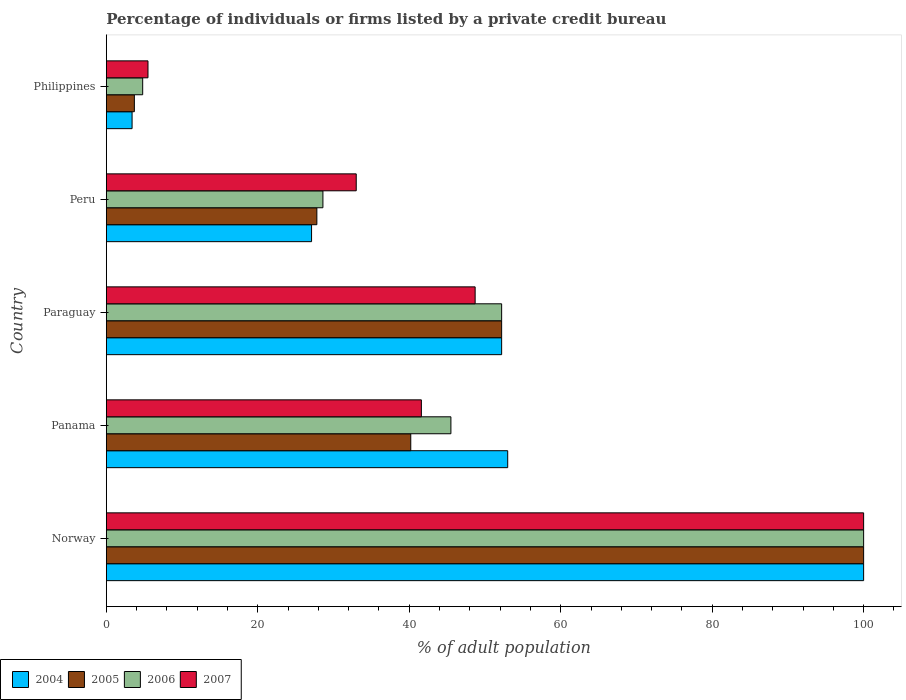Are the number of bars per tick equal to the number of legend labels?
Give a very brief answer. Yes. What is the label of the 4th group of bars from the top?
Provide a succinct answer. Panama. What is the percentage of population listed by a private credit bureau in 2006 in Peru?
Provide a succinct answer. 28.6. Across all countries, what is the maximum percentage of population listed by a private credit bureau in 2006?
Keep it short and to the point. 100. What is the total percentage of population listed by a private credit bureau in 2004 in the graph?
Provide a succinct answer. 235.7. What is the difference between the percentage of population listed by a private credit bureau in 2004 in Norway and that in Panama?
Make the answer very short. 47. What is the difference between the percentage of population listed by a private credit bureau in 2007 in Norway and the percentage of population listed by a private credit bureau in 2006 in Philippines?
Keep it short and to the point. 95.2. What is the average percentage of population listed by a private credit bureau in 2007 per country?
Your answer should be compact. 45.76. What is the difference between the percentage of population listed by a private credit bureau in 2006 and percentage of population listed by a private credit bureau in 2004 in Peru?
Your answer should be compact. 1.5. In how many countries, is the percentage of population listed by a private credit bureau in 2004 greater than 48 %?
Your answer should be compact. 3. What is the ratio of the percentage of population listed by a private credit bureau in 2004 in Panama to that in Philippines?
Offer a terse response. 15.59. Is the difference between the percentage of population listed by a private credit bureau in 2006 in Paraguay and Peru greater than the difference between the percentage of population listed by a private credit bureau in 2004 in Paraguay and Peru?
Ensure brevity in your answer.  No. What is the difference between the highest and the second highest percentage of population listed by a private credit bureau in 2004?
Your response must be concise. 47. What is the difference between the highest and the lowest percentage of population listed by a private credit bureau in 2004?
Provide a short and direct response. 96.6. In how many countries, is the percentage of population listed by a private credit bureau in 2007 greater than the average percentage of population listed by a private credit bureau in 2007 taken over all countries?
Your response must be concise. 2. Is the sum of the percentage of population listed by a private credit bureau in 2004 in Panama and Philippines greater than the maximum percentage of population listed by a private credit bureau in 2007 across all countries?
Offer a very short reply. No. Is it the case that in every country, the sum of the percentage of population listed by a private credit bureau in 2006 and percentage of population listed by a private credit bureau in 2005 is greater than the sum of percentage of population listed by a private credit bureau in 2007 and percentage of population listed by a private credit bureau in 2004?
Your answer should be very brief. No. What does the 2nd bar from the bottom in Paraguay represents?
Offer a terse response. 2005. Is it the case that in every country, the sum of the percentage of population listed by a private credit bureau in 2005 and percentage of population listed by a private credit bureau in 2006 is greater than the percentage of population listed by a private credit bureau in 2007?
Your answer should be very brief. Yes. How many bars are there?
Ensure brevity in your answer.  20. Are all the bars in the graph horizontal?
Provide a short and direct response. Yes. Where does the legend appear in the graph?
Keep it short and to the point. Bottom left. How many legend labels are there?
Provide a short and direct response. 4. How are the legend labels stacked?
Provide a succinct answer. Horizontal. What is the title of the graph?
Offer a terse response. Percentage of individuals or firms listed by a private credit bureau. What is the label or title of the X-axis?
Ensure brevity in your answer.  % of adult population. What is the % of adult population in 2005 in Norway?
Your answer should be compact. 100. What is the % of adult population in 2006 in Norway?
Provide a short and direct response. 100. What is the % of adult population in 2007 in Norway?
Offer a very short reply. 100. What is the % of adult population of 2004 in Panama?
Keep it short and to the point. 53. What is the % of adult population in 2005 in Panama?
Give a very brief answer. 40.2. What is the % of adult population in 2006 in Panama?
Offer a terse response. 45.5. What is the % of adult population of 2007 in Panama?
Provide a succinct answer. 41.6. What is the % of adult population of 2004 in Paraguay?
Your answer should be compact. 52.2. What is the % of adult population of 2005 in Paraguay?
Your answer should be very brief. 52.2. What is the % of adult population in 2006 in Paraguay?
Keep it short and to the point. 52.2. What is the % of adult population in 2007 in Paraguay?
Provide a short and direct response. 48.7. What is the % of adult population of 2004 in Peru?
Offer a very short reply. 27.1. What is the % of adult population of 2005 in Peru?
Provide a succinct answer. 27.8. What is the % of adult population in 2006 in Peru?
Keep it short and to the point. 28.6. What is the % of adult population of 2007 in Peru?
Your response must be concise. 33. What is the % of adult population of 2004 in Philippines?
Provide a short and direct response. 3.4. What is the % of adult population in 2005 in Philippines?
Offer a very short reply. 3.7. What is the % of adult population of 2007 in Philippines?
Ensure brevity in your answer.  5.5. Across all countries, what is the maximum % of adult population in 2006?
Ensure brevity in your answer.  100. Across all countries, what is the minimum % of adult population of 2006?
Your answer should be very brief. 4.8. What is the total % of adult population in 2004 in the graph?
Ensure brevity in your answer.  235.7. What is the total % of adult population of 2005 in the graph?
Give a very brief answer. 223.9. What is the total % of adult population in 2006 in the graph?
Your response must be concise. 231.1. What is the total % of adult population in 2007 in the graph?
Make the answer very short. 228.8. What is the difference between the % of adult population in 2005 in Norway and that in Panama?
Offer a terse response. 59.8. What is the difference between the % of adult population of 2006 in Norway and that in Panama?
Provide a short and direct response. 54.5. What is the difference between the % of adult population in 2007 in Norway and that in Panama?
Your answer should be very brief. 58.4. What is the difference between the % of adult population of 2004 in Norway and that in Paraguay?
Make the answer very short. 47.8. What is the difference between the % of adult population in 2005 in Norway and that in Paraguay?
Keep it short and to the point. 47.8. What is the difference between the % of adult population of 2006 in Norway and that in Paraguay?
Give a very brief answer. 47.8. What is the difference between the % of adult population of 2007 in Norway and that in Paraguay?
Offer a very short reply. 51.3. What is the difference between the % of adult population in 2004 in Norway and that in Peru?
Your answer should be very brief. 72.9. What is the difference between the % of adult population of 2005 in Norway and that in Peru?
Keep it short and to the point. 72.2. What is the difference between the % of adult population in 2006 in Norway and that in Peru?
Give a very brief answer. 71.4. What is the difference between the % of adult population of 2007 in Norway and that in Peru?
Ensure brevity in your answer.  67. What is the difference between the % of adult population of 2004 in Norway and that in Philippines?
Offer a very short reply. 96.6. What is the difference between the % of adult population of 2005 in Norway and that in Philippines?
Offer a terse response. 96.3. What is the difference between the % of adult population in 2006 in Norway and that in Philippines?
Ensure brevity in your answer.  95.2. What is the difference between the % of adult population of 2007 in Norway and that in Philippines?
Your response must be concise. 94.5. What is the difference between the % of adult population of 2006 in Panama and that in Paraguay?
Keep it short and to the point. -6.7. What is the difference between the % of adult population in 2004 in Panama and that in Peru?
Offer a very short reply. 25.9. What is the difference between the % of adult population of 2005 in Panama and that in Peru?
Ensure brevity in your answer.  12.4. What is the difference between the % of adult population in 2004 in Panama and that in Philippines?
Give a very brief answer. 49.6. What is the difference between the % of adult population of 2005 in Panama and that in Philippines?
Give a very brief answer. 36.5. What is the difference between the % of adult population of 2006 in Panama and that in Philippines?
Offer a terse response. 40.7. What is the difference between the % of adult population in 2007 in Panama and that in Philippines?
Give a very brief answer. 36.1. What is the difference between the % of adult population in 2004 in Paraguay and that in Peru?
Offer a terse response. 25.1. What is the difference between the % of adult population in 2005 in Paraguay and that in Peru?
Offer a terse response. 24.4. What is the difference between the % of adult population in 2006 in Paraguay and that in Peru?
Offer a terse response. 23.6. What is the difference between the % of adult population in 2007 in Paraguay and that in Peru?
Give a very brief answer. 15.7. What is the difference between the % of adult population in 2004 in Paraguay and that in Philippines?
Your answer should be very brief. 48.8. What is the difference between the % of adult population in 2005 in Paraguay and that in Philippines?
Ensure brevity in your answer.  48.5. What is the difference between the % of adult population of 2006 in Paraguay and that in Philippines?
Offer a very short reply. 47.4. What is the difference between the % of adult population of 2007 in Paraguay and that in Philippines?
Provide a succinct answer. 43.2. What is the difference between the % of adult population of 2004 in Peru and that in Philippines?
Provide a succinct answer. 23.7. What is the difference between the % of adult population of 2005 in Peru and that in Philippines?
Make the answer very short. 24.1. What is the difference between the % of adult population of 2006 in Peru and that in Philippines?
Your answer should be very brief. 23.8. What is the difference between the % of adult population of 2007 in Peru and that in Philippines?
Your answer should be compact. 27.5. What is the difference between the % of adult population of 2004 in Norway and the % of adult population of 2005 in Panama?
Offer a very short reply. 59.8. What is the difference between the % of adult population in 2004 in Norway and the % of adult population in 2006 in Panama?
Provide a short and direct response. 54.5. What is the difference between the % of adult population of 2004 in Norway and the % of adult population of 2007 in Panama?
Provide a succinct answer. 58.4. What is the difference between the % of adult population in 2005 in Norway and the % of adult population in 2006 in Panama?
Your response must be concise. 54.5. What is the difference between the % of adult population of 2005 in Norway and the % of adult population of 2007 in Panama?
Keep it short and to the point. 58.4. What is the difference between the % of adult population in 2006 in Norway and the % of adult population in 2007 in Panama?
Provide a short and direct response. 58.4. What is the difference between the % of adult population in 2004 in Norway and the % of adult population in 2005 in Paraguay?
Offer a terse response. 47.8. What is the difference between the % of adult population of 2004 in Norway and the % of adult population of 2006 in Paraguay?
Ensure brevity in your answer.  47.8. What is the difference between the % of adult population in 2004 in Norway and the % of adult population in 2007 in Paraguay?
Make the answer very short. 51.3. What is the difference between the % of adult population in 2005 in Norway and the % of adult population in 2006 in Paraguay?
Your answer should be compact. 47.8. What is the difference between the % of adult population of 2005 in Norway and the % of adult population of 2007 in Paraguay?
Offer a terse response. 51.3. What is the difference between the % of adult population in 2006 in Norway and the % of adult population in 2007 in Paraguay?
Provide a succinct answer. 51.3. What is the difference between the % of adult population in 2004 in Norway and the % of adult population in 2005 in Peru?
Make the answer very short. 72.2. What is the difference between the % of adult population of 2004 in Norway and the % of adult population of 2006 in Peru?
Ensure brevity in your answer.  71.4. What is the difference between the % of adult population in 2005 in Norway and the % of adult population in 2006 in Peru?
Offer a very short reply. 71.4. What is the difference between the % of adult population of 2006 in Norway and the % of adult population of 2007 in Peru?
Make the answer very short. 67. What is the difference between the % of adult population of 2004 in Norway and the % of adult population of 2005 in Philippines?
Give a very brief answer. 96.3. What is the difference between the % of adult population of 2004 in Norway and the % of adult population of 2006 in Philippines?
Give a very brief answer. 95.2. What is the difference between the % of adult population of 2004 in Norway and the % of adult population of 2007 in Philippines?
Your answer should be very brief. 94.5. What is the difference between the % of adult population of 2005 in Norway and the % of adult population of 2006 in Philippines?
Offer a terse response. 95.2. What is the difference between the % of adult population in 2005 in Norway and the % of adult population in 2007 in Philippines?
Provide a short and direct response. 94.5. What is the difference between the % of adult population in 2006 in Norway and the % of adult population in 2007 in Philippines?
Your response must be concise. 94.5. What is the difference between the % of adult population in 2005 in Panama and the % of adult population in 2007 in Paraguay?
Your answer should be compact. -8.5. What is the difference between the % of adult population in 2006 in Panama and the % of adult population in 2007 in Paraguay?
Offer a terse response. -3.2. What is the difference between the % of adult population in 2004 in Panama and the % of adult population in 2005 in Peru?
Make the answer very short. 25.2. What is the difference between the % of adult population in 2004 in Panama and the % of adult population in 2006 in Peru?
Keep it short and to the point. 24.4. What is the difference between the % of adult population in 2004 in Panama and the % of adult population in 2007 in Peru?
Make the answer very short. 20. What is the difference between the % of adult population in 2005 in Panama and the % of adult population in 2006 in Peru?
Offer a very short reply. 11.6. What is the difference between the % of adult population of 2005 in Panama and the % of adult population of 2007 in Peru?
Make the answer very short. 7.2. What is the difference between the % of adult population of 2006 in Panama and the % of adult population of 2007 in Peru?
Make the answer very short. 12.5. What is the difference between the % of adult population in 2004 in Panama and the % of adult population in 2005 in Philippines?
Ensure brevity in your answer.  49.3. What is the difference between the % of adult population in 2004 in Panama and the % of adult population in 2006 in Philippines?
Keep it short and to the point. 48.2. What is the difference between the % of adult population in 2004 in Panama and the % of adult population in 2007 in Philippines?
Offer a very short reply. 47.5. What is the difference between the % of adult population of 2005 in Panama and the % of adult population of 2006 in Philippines?
Make the answer very short. 35.4. What is the difference between the % of adult population in 2005 in Panama and the % of adult population in 2007 in Philippines?
Give a very brief answer. 34.7. What is the difference between the % of adult population in 2006 in Panama and the % of adult population in 2007 in Philippines?
Keep it short and to the point. 40. What is the difference between the % of adult population in 2004 in Paraguay and the % of adult population in 2005 in Peru?
Provide a short and direct response. 24.4. What is the difference between the % of adult population in 2004 in Paraguay and the % of adult population in 2006 in Peru?
Make the answer very short. 23.6. What is the difference between the % of adult population in 2004 in Paraguay and the % of adult population in 2007 in Peru?
Provide a short and direct response. 19.2. What is the difference between the % of adult population of 2005 in Paraguay and the % of adult population of 2006 in Peru?
Your answer should be compact. 23.6. What is the difference between the % of adult population in 2005 in Paraguay and the % of adult population in 2007 in Peru?
Offer a terse response. 19.2. What is the difference between the % of adult population of 2004 in Paraguay and the % of adult population of 2005 in Philippines?
Offer a very short reply. 48.5. What is the difference between the % of adult population of 2004 in Paraguay and the % of adult population of 2006 in Philippines?
Ensure brevity in your answer.  47.4. What is the difference between the % of adult population of 2004 in Paraguay and the % of adult population of 2007 in Philippines?
Your answer should be very brief. 46.7. What is the difference between the % of adult population in 2005 in Paraguay and the % of adult population in 2006 in Philippines?
Give a very brief answer. 47.4. What is the difference between the % of adult population in 2005 in Paraguay and the % of adult population in 2007 in Philippines?
Ensure brevity in your answer.  46.7. What is the difference between the % of adult population of 2006 in Paraguay and the % of adult population of 2007 in Philippines?
Provide a short and direct response. 46.7. What is the difference between the % of adult population of 2004 in Peru and the % of adult population of 2005 in Philippines?
Give a very brief answer. 23.4. What is the difference between the % of adult population of 2004 in Peru and the % of adult population of 2006 in Philippines?
Give a very brief answer. 22.3. What is the difference between the % of adult population in 2004 in Peru and the % of adult population in 2007 in Philippines?
Keep it short and to the point. 21.6. What is the difference between the % of adult population in 2005 in Peru and the % of adult population in 2007 in Philippines?
Your response must be concise. 22.3. What is the difference between the % of adult population of 2006 in Peru and the % of adult population of 2007 in Philippines?
Your answer should be compact. 23.1. What is the average % of adult population of 2004 per country?
Your answer should be compact. 47.14. What is the average % of adult population in 2005 per country?
Your answer should be compact. 44.78. What is the average % of adult population in 2006 per country?
Ensure brevity in your answer.  46.22. What is the average % of adult population of 2007 per country?
Make the answer very short. 45.76. What is the difference between the % of adult population of 2004 and % of adult population of 2006 in Norway?
Provide a short and direct response. 0. What is the difference between the % of adult population of 2004 and % of adult population of 2007 in Norway?
Offer a terse response. 0. What is the difference between the % of adult population of 2005 and % of adult population of 2006 in Norway?
Provide a succinct answer. 0. What is the difference between the % of adult population in 2004 and % of adult population in 2005 in Panama?
Ensure brevity in your answer.  12.8. What is the difference between the % of adult population of 2005 and % of adult population of 2006 in Panama?
Give a very brief answer. -5.3. What is the difference between the % of adult population in 2005 and % of adult population in 2007 in Panama?
Make the answer very short. -1.4. What is the difference between the % of adult population in 2006 and % of adult population in 2007 in Panama?
Your response must be concise. 3.9. What is the difference between the % of adult population in 2004 and % of adult population in 2005 in Paraguay?
Give a very brief answer. 0. What is the difference between the % of adult population of 2004 and % of adult population of 2006 in Paraguay?
Offer a terse response. 0. What is the difference between the % of adult population of 2004 and % of adult population of 2007 in Paraguay?
Your answer should be compact. 3.5. What is the difference between the % of adult population in 2005 and % of adult population in 2006 in Paraguay?
Ensure brevity in your answer.  0. What is the difference between the % of adult population of 2004 and % of adult population of 2006 in Peru?
Provide a succinct answer. -1.5. What is the difference between the % of adult population of 2005 and % of adult population of 2006 in Peru?
Your answer should be compact. -0.8. What is the difference between the % of adult population of 2006 and % of adult population of 2007 in Peru?
Offer a very short reply. -4.4. What is the ratio of the % of adult population of 2004 in Norway to that in Panama?
Give a very brief answer. 1.89. What is the ratio of the % of adult population of 2005 in Norway to that in Panama?
Keep it short and to the point. 2.49. What is the ratio of the % of adult population of 2006 in Norway to that in Panama?
Keep it short and to the point. 2.2. What is the ratio of the % of adult population in 2007 in Norway to that in Panama?
Your response must be concise. 2.4. What is the ratio of the % of adult population in 2004 in Norway to that in Paraguay?
Give a very brief answer. 1.92. What is the ratio of the % of adult population of 2005 in Norway to that in Paraguay?
Offer a terse response. 1.92. What is the ratio of the % of adult population in 2006 in Norway to that in Paraguay?
Provide a short and direct response. 1.92. What is the ratio of the % of adult population of 2007 in Norway to that in Paraguay?
Ensure brevity in your answer.  2.05. What is the ratio of the % of adult population in 2004 in Norway to that in Peru?
Make the answer very short. 3.69. What is the ratio of the % of adult population in 2005 in Norway to that in Peru?
Ensure brevity in your answer.  3.6. What is the ratio of the % of adult population in 2006 in Norway to that in Peru?
Offer a terse response. 3.5. What is the ratio of the % of adult population in 2007 in Norway to that in Peru?
Keep it short and to the point. 3.03. What is the ratio of the % of adult population of 2004 in Norway to that in Philippines?
Make the answer very short. 29.41. What is the ratio of the % of adult population of 2005 in Norway to that in Philippines?
Provide a short and direct response. 27.03. What is the ratio of the % of adult population in 2006 in Norway to that in Philippines?
Give a very brief answer. 20.83. What is the ratio of the % of adult population of 2007 in Norway to that in Philippines?
Your answer should be compact. 18.18. What is the ratio of the % of adult population of 2004 in Panama to that in Paraguay?
Keep it short and to the point. 1.02. What is the ratio of the % of adult population in 2005 in Panama to that in Paraguay?
Offer a very short reply. 0.77. What is the ratio of the % of adult population of 2006 in Panama to that in Paraguay?
Your answer should be very brief. 0.87. What is the ratio of the % of adult population in 2007 in Panama to that in Paraguay?
Make the answer very short. 0.85. What is the ratio of the % of adult population in 2004 in Panama to that in Peru?
Keep it short and to the point. 1.96. What is the ratio of the % of adult population in 2005 in Panama to that in Peru?
Keep it short and to the point. 1.45. What is the ratio of the % of adult population in 2006 in Panama to that in Peru?
Give a very brief answer. 1.59. What is the ratio of the % of adult population in 2007 in Panama to that in Peru?
Your response must be concise. 1.26. What is the ratio of the % of adult population in 2004 in Panama to that in Philippines?
Provide a short and direct response. 15.59. What is the ratio of the % of adult population of 2005 in Panama to that in Philippines?
Keep it short and to the point. 10.86. What is the ratio of the % of adult population of 2006 in Panama to that in Philippines?
Give a very brief answer. 9.48. What is the ratio of the % of adult population in 2007 in Panama to that in Philippines?
Provide a succinct answer. 7.56. What is the ratio of the % of adult population of 2004 in Paraguay to that in Peru?
Give a very brief answer. 1.93. What is the ratio of the % of adult population in 2005 in Paraguay to that in Peru?
Make the answer very short. 1.88. What is the ratio of the % of adult population in 2006 in Paraguay to that in Peru?
Your answer should be very brief. 1.83. What is the ratio of the % of adult population in 2007 in Paraguay to that in Peru?
Keep it short and to the point. 1.48. What is the ratio of the % of adult population in 2004 in Paraguay to that in Philippines?
Provide a succinct answer. 15.35. What is the ratio of the % of adult population of 2005 in Paraguay to that in Philippines?
Offer a very short reply. 14.11. What is the ratio of the % of adult population of 2006 in Paraguay to that in Philippines?
Provide a short and direct response. 10.88. What is the ratio of the % of adult population of 2007 in Paraguay to that in Philippines?
Your answer should be compact. 8.85. What is the ratio of the % of adult population of 2004 in Peru to that in Philippines?
Offer a very short reply. 7.97. What is the ratio of the % of adult population in 2005 in Peru to that in Philippines?
Offer a terse response. 7.51. What is the ratio of the % of adult population of 2006 in Peru to that in Philippines?
Provide a succinct answer. 5.96. What is the ratio of the % of adult population in 2007 in Peru to that in Philippines?
Provide a short and direct response. 6. What is the difference between the highest and the second highest % of adult population in 2005?
Give a very brief answer. 47.8. What is the difference between the highest and the second highest % of adult population in 2006?
Ensure brevity in your answer.  47.8. What is the difference between the highest and the second highest % of adult population of 2007?
Provide a short and direct response. 51.3. What is the difference between the highest and the lowest % of adult population of 2004?
Offer a terse response. 96.6. What is the difference between the highest and the lowest % of adult population in 2005?
Give a very brief answer. 96.3. What is the difference between the highest and the lowest % of adult population of 2006?
Make the answer very short. 95.2. What is the difference between the highest and the lowest % of adult population in 2007?
Your answer should be very brief. 94.5. 